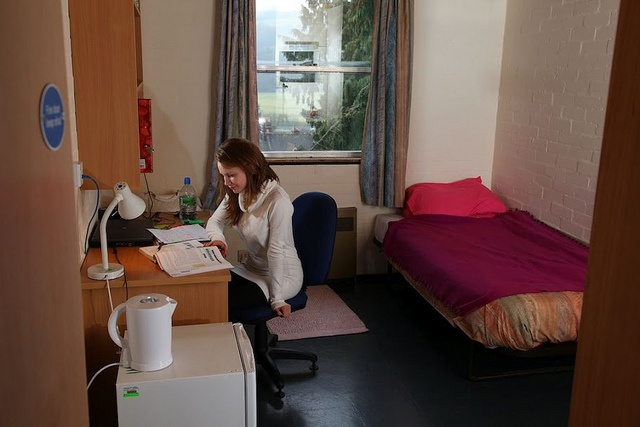Describe the objects in this image and their specific colors. I can see bed in maroon, black, and brown tones, people in maroon, black, darkgray, and gray tones, refrigerator in maroon and gray tones, chair in maroon, black, and gray tones, and book in maroon, darkgray, gray, and tan tones in this image. 